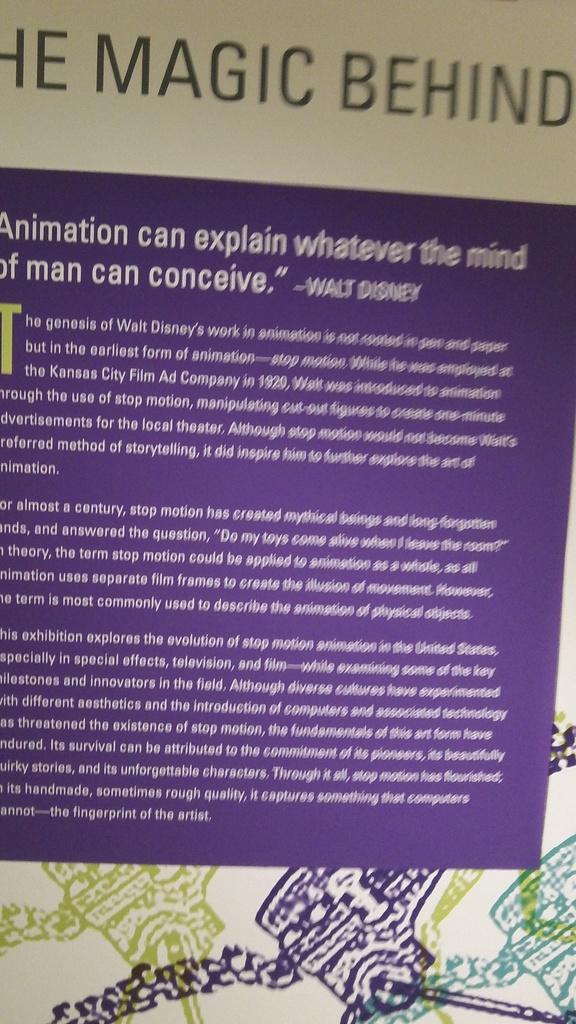Who is the author of this quote?
Your answer should be compact. Walt disney. 